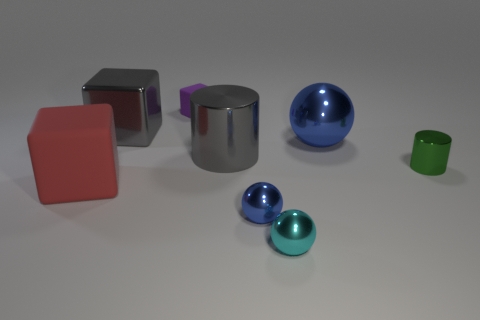Add 1 small matte blocks. How many objects exist? 9 Subtract all cylinders. How many objects are left? 6 Add 1 purple things. How many purple things are left? 2 Add 4 small purple matte blocks. How many small purple matte blocks exist? 5 Subtract 0 gray balls. How many objects are left? 8 Subtract all large purple cubes. Subtract all cyan shiny objects. How many objects are left? 7 